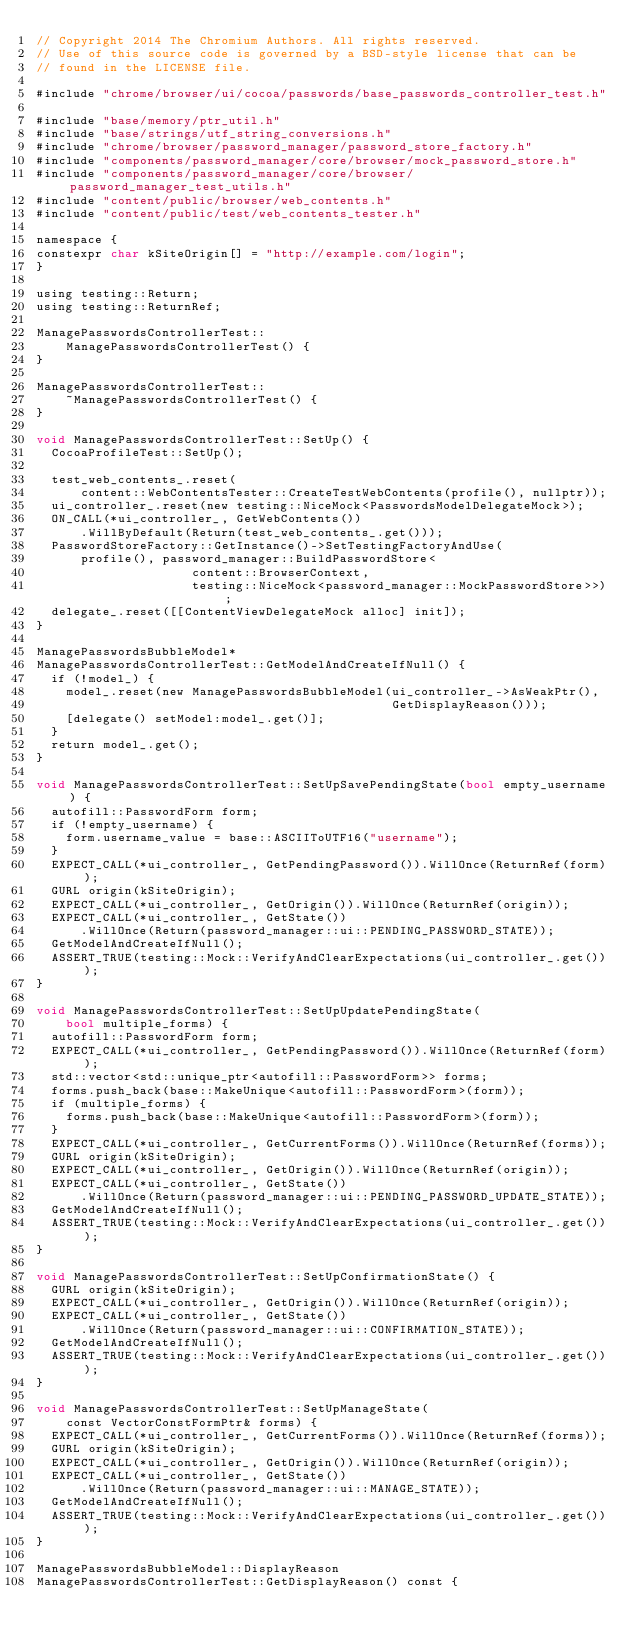<code> <loc_0><loc_0><loc_500><loc_500><_ObjectiveC_>// Copyright 2014 The Chromium Authors. All rights reserved.
// Use of this source code is governed by a BSD-style license that can be
// found in the LICENSE file.

#include "chrome/browser/ui/cocoa/passwords/base_passwords_controller_test.h"

#include "base/memory/ptr_util.h"
#include "base/strings/utf_string_conversions.h"
#include "chrome/browser/password_manager/password_store_factory.h"
#include "components/password_manager/core/browser/mock_password_store.h"
#include "components/password_manager/core/browser/password_manager_test_utils.h"
#include "content/public/browser/web_contents.h"
#include "content/public/test/web_contents_tester.h"

namespace {
constexpr char kSiteOrigin[] = "http://example.com/login";
}

using testing::Return;
using testing::ReturnRef;

ManagePasswordsControllerTest::
    ManagePasswordsControllerTest() {
}

ManagePasswordsControllerTest::
    ~ManagePasswordsControllerTest() {
}

void ManagePasswordsControllerTest::SetUp() {
  CocoaProfileTest::SetUp();

  test_web_contents_.reset(
      content::WebContentsTester::CreateTestWebContents(profile(), nullptr));
  ui_controller_.reset(new testing::NiceMock<PasswordsModelDelegateMock>);
  ON_CALL(*ui_controller_, GetWebContents())
      .WillByDefault(Return(test_web_contents_.get()));
  PasswordStoreFactory::GetInstance()->SetTestingFactoryAndUse(
      profile(), password_manager::BuildPasswordStore<
                     content::BrowserContext,
                     testing::NiceMock<password_manager::MockPasswordStore>>);
  delegate_.reset([[ContentViewDelegateMock alloc] init]);
}

ManagePasswordsBubbleModel*
ManagePasswordsControllerTest::GetModelAndCreateIfNull() {
  if (!model_) {
    model_.reset(new ManagePasswordsBubbleModel(ui_controller_->AsWeakPtr(),
                                                GetDisplayReason()));
    [delegate() setModel:model_.get()];
  }
  return model_.get();
}

void ManagePasswordsControllerTest::SetUpSavePendingState(bool empty_username) {
  autofill::PasswordForm form;
  if (!empty_username) {
    form.username_value = base::ASCIIToUTF16("username");
  }
  EXPECT_CALL(*ui_controller_, GetPendingPassword()).WillOnce(ReturnRef(form));
  GURL origin(kSiteOrigin);
  EXPECT_CALL(*ui_controller_, GetOrigin()).WillOnce(ReturnRef(origin));
  EXPECT_CALL(*ui_controller_, GetState())
      .WillOnce(Return(password_manager::ui::PENDING_PASSWORD_STATE));
  GetModelAndCreateIfNull();
  ASSERT_TRUE(testing::Mock::VerifyAndClearExpectations(ui_controller_.get()));
}

void ManagePasswordsControllerTest::SetUpUpdatePendingState(
    bool multiple_forms) {
  autofill::PasswordForm form;
  EXPECT_CALL(*ui_controller_, GetPendingPassword()).WillOnce(ReturnRef(form));
  std::vector<std::unique_ptr<autofill::PasswordForm>> forms;
  forms.push_back(base::MakeUnique<autofill::PasswordForm>(form));
  if (multiple_forms) {
    forms.push_back(base::MakeUnique<autofill::PasswordForm>(form));
  }
  EXPECT_CALL(*ui_controller_, GetCurrentForms()).WillOnce(ReturnRef(forms));
  GURL origin(kSiteOrigin);
  EXPECT_CALL(*ui_controller_, GetOrigin()).WillOnce(ReturnRef(origin));
  EXPECT_CALL(*ui_controller_, GetState())
      .WillOnce(Return(password_manager::ui::PENDING_PASSWORD_UPDATE_STATE));
  GetModelAndCreateIfNull();
  ASSERT_TRUE(testing::Mock::VerifyAndClearExpectations(ui_controller_.get()));
}

void ManagePasswordsControllerTest::SetUpConfirmationState() {
  GURL origin(kSiteOrigin);
  EXPECT_CALL(*ui_controller_, GetOrigin()).WillOnce(ReturnRef(origin));
  EXPECT_CALL(*ui_controller_, GetState())
      .WillOnce(Return(password_manager::ui::CONFIRMATION_STATE));
  GetModelAndCreateIfNull();
  ASSERT_TRUE(testing::Mock::VerifyAndClearExpectations(ui_controller_.get()));
}

void ManagePasswordsControllerTest::SetUpManageState(
    const VectorConstFormPtr& forms) {
  EXPECT_CALL(*ui_controller_, GetCurrentForms()).WillOnce(ReturnRef(forms));
  GURL origin(kSiteOrigin);
  EXPECT_CALL(*ui_controller_, GetOrigin()).WillOnce(ReturnRef(origin));
  EXPECT_CALL(*ui_controller_, GetState())
      .WillOnce(Return(password_manager::ui::MANAGE_STATE));
  GetModelAndCreateIfNull();
  ASSERT_TRUE(testing::Mock::VerifyAndClearExpectations(ui_controller_.get()));
}

ManagePasswordsBubbleModel::DisplayReason
ManagePasswordsControllerTest::GetDisplayReason() const {</code> 